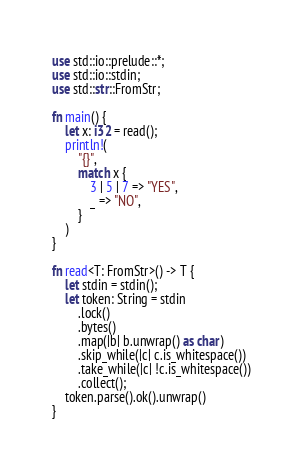<code> <loc_0><loc_0><loc_500><loc_500><_Rust_>use std::io::prelude::*;
use std::io::stdin;
use std::str::FromStr;

fn main() {
    let x: i32 = read();
    println!(
        "{}",
        match x {
            3 | 5 | 7 => "YES",
            _ => "NO",
        }
    )
}

fn read<T: FromStr>() -> T {
    let stdin = stdin();
    let token: String = stdin
        .lock()
        .bytes()
        .map(|b| b.unwrap() as char)
        .skip_while(|c| c.is_whitespace())
        .take_while(|c| !c.is_whitespace())
        .collect();
    token.parse().ok().unwrap()
}
</code> 